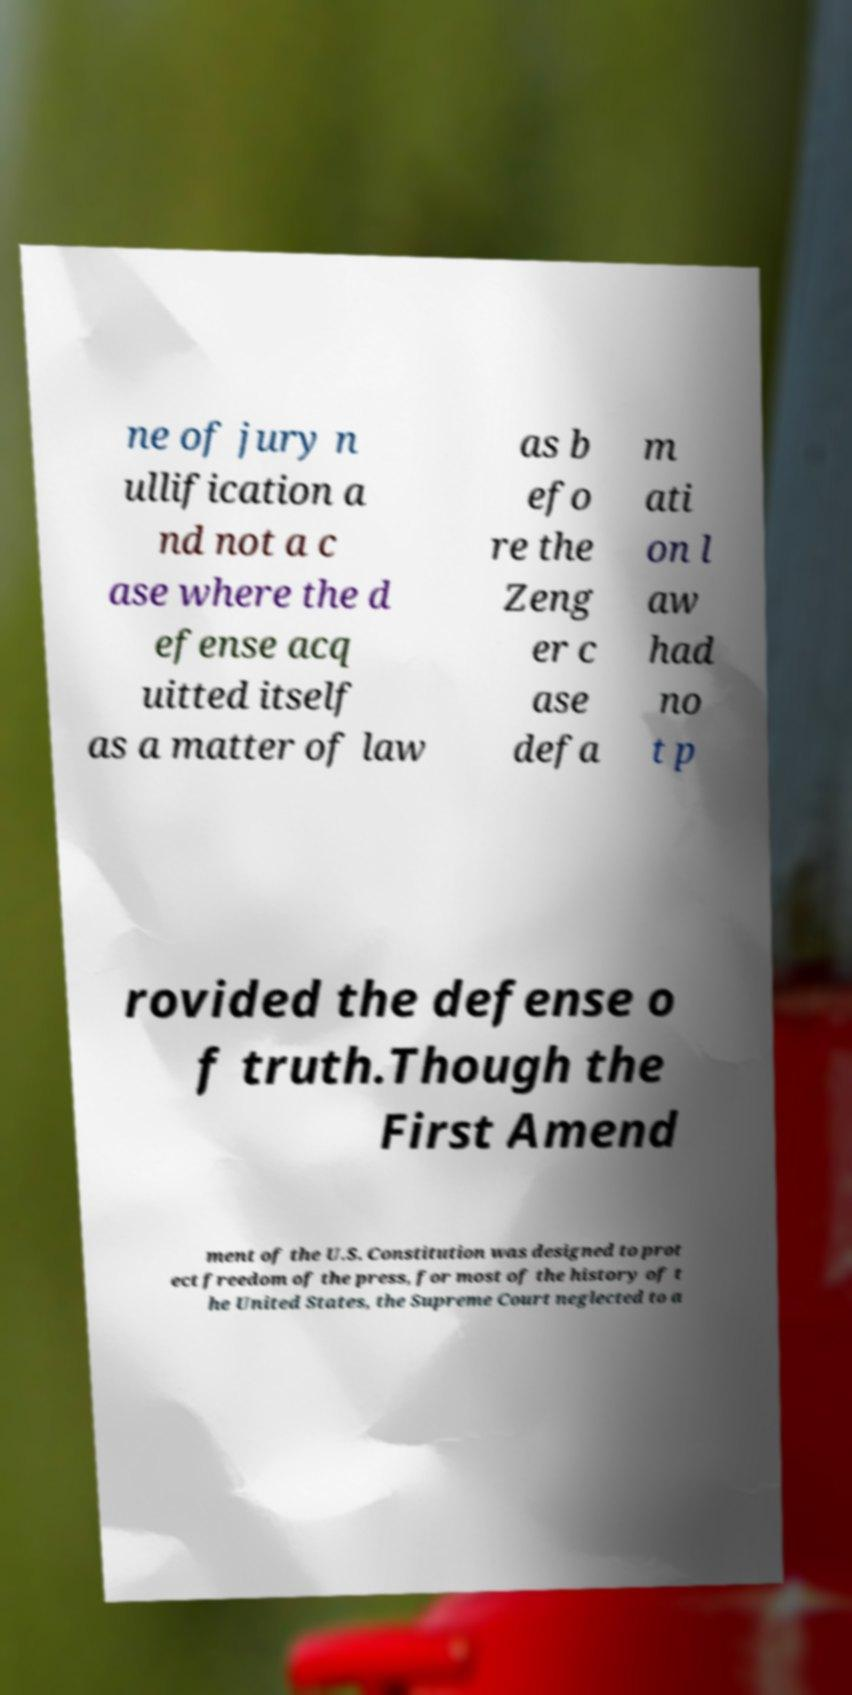Please identify and transcribe the text found in this image. ne of jury n ullification a nd not a c ase where the d efense acq uitted itself as a matter of law as b efo re the Zeng er c ase defa m ati on l aw had no t p rovided the defense o f truth.Though the First Amend ment of the U.S. Constitution was designed to prot ect freedom of the press, for most of the history of t he United States, the Supreme Court neglected to a 